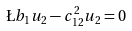Convert formula to latex. <formula><loc_0><loc_0><loc_500><loc_500>\L b _ { 1 } u _ { 2 } - c _ { 1 2 } ^ { 2 } u _ { 2 } = 0</formula> 